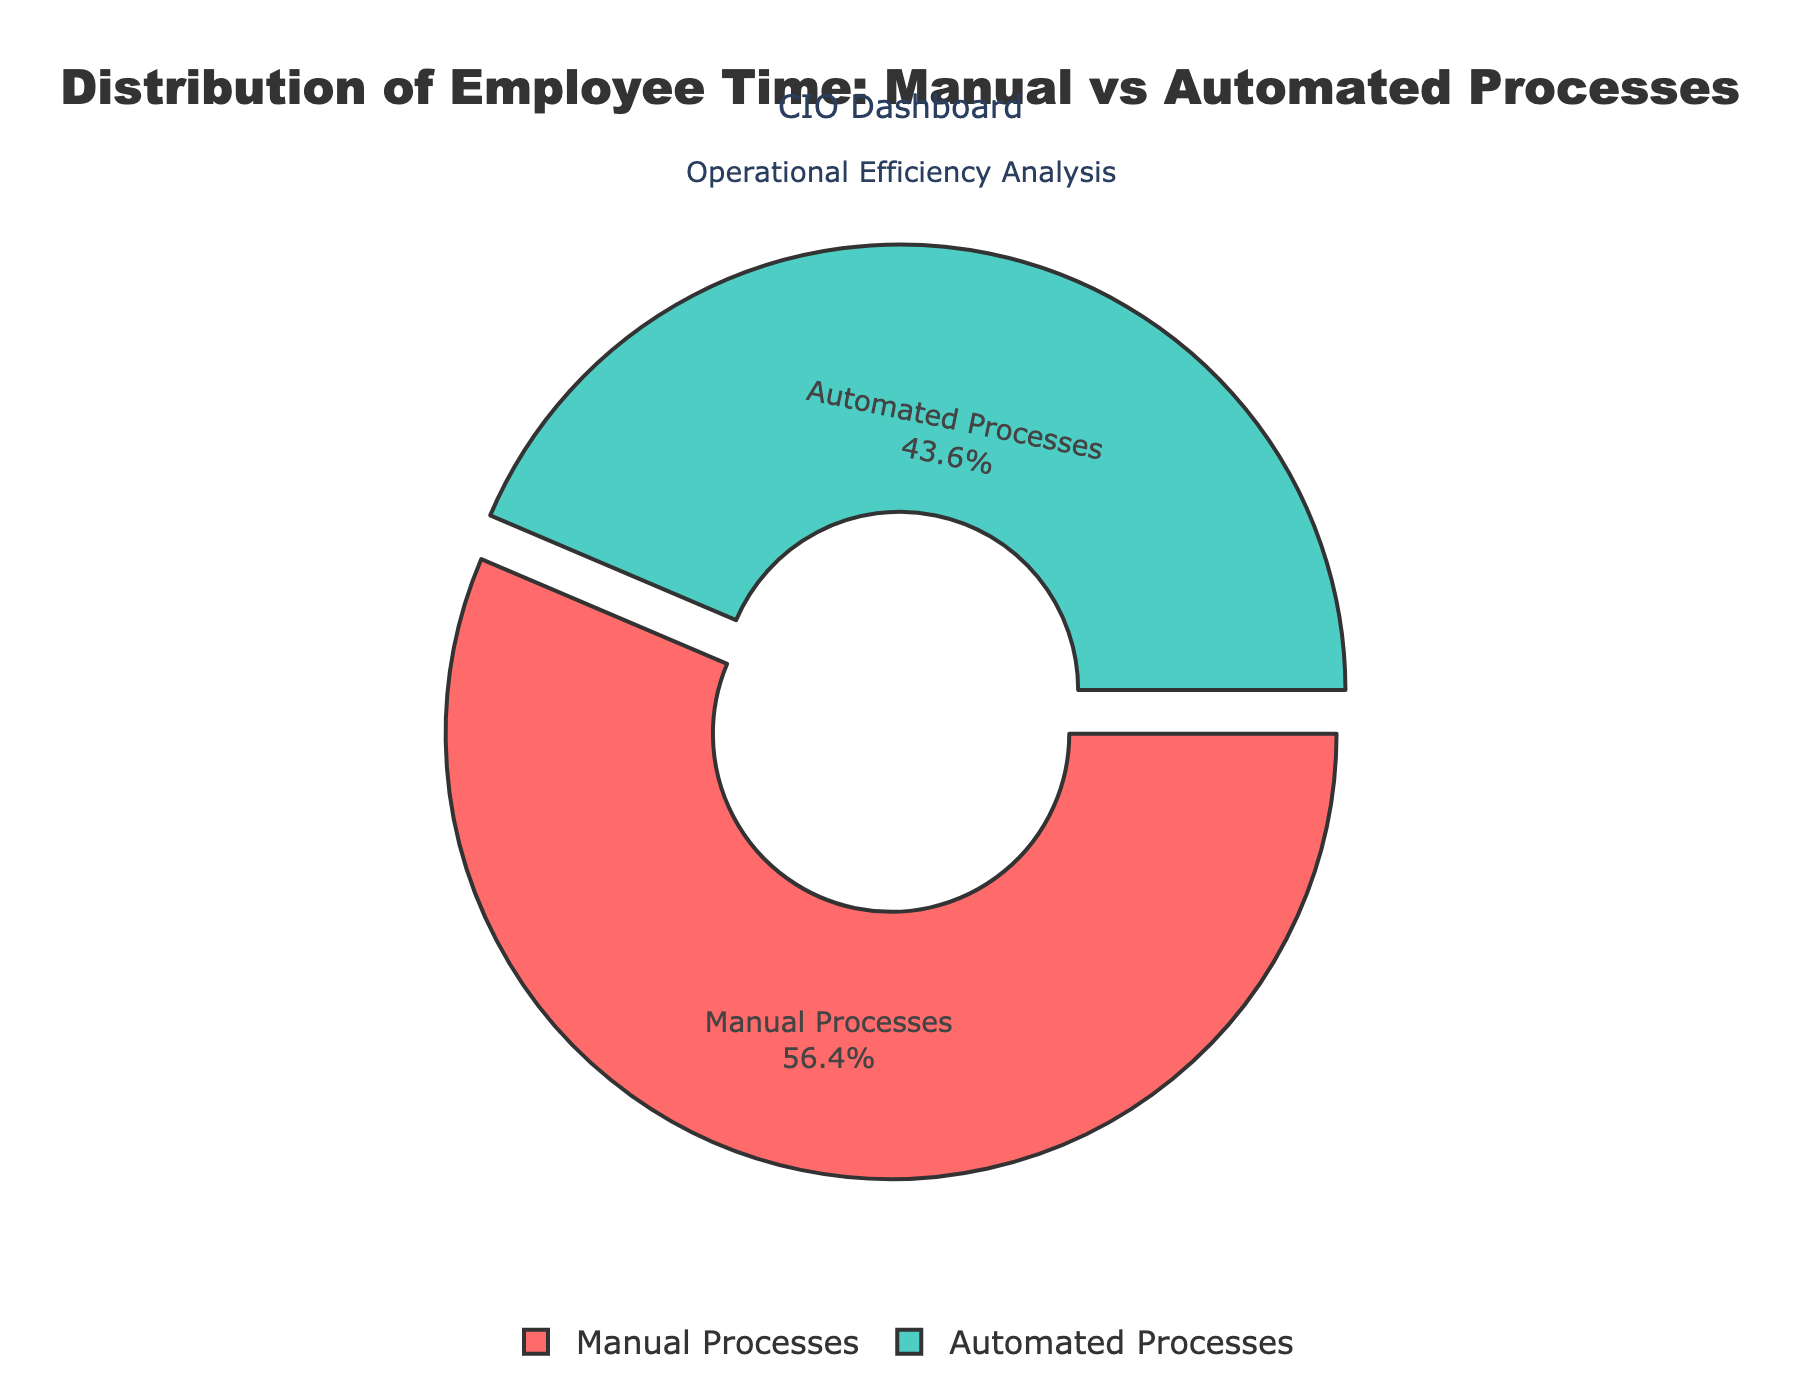What percentage of employee time is spent on manual processes compared to automated processes? The pie chart shows two segments, one for manual processes and one for automated processes. Looking at the chart, you can directly see the percentage labels.
Answer: Manual: 65%, Automated: 35% Which process type, manual or automated, occupies the larger portion of the pie chart? The pie chart segment labeled "Manual Processes" is larger than the one labeled "Automated Processes," which is evident by looking at the size of the sections.
Answer: Manual Processes What is the combined percentage of time spent on manual data entry and automated data processing? To find the combined percentage, sum the individual percentages for "Manual Data Entry" and "Automated Data Processing." The values are 25% and 35%, respectively. Adding these, 25 + 35 = 60%.
Answer: 60% Is the percentage of time spent on manual report generation greater than, less than, or equal to the time spent on automated reporting? Compare the pie chart segments labeled "Manual Report Generation" (15%) and "Automated Reporting" (20%). It's clear that 15% is less than 20%.
Answer: Less than What is the difference in percentage between time spent on manual compliance checks and automated compliance monitoring? Subtract the percentage for "Automated Compliance Monitoring" (8%) from "Manual Compliance Checks" (12%). So, 12 - 8 = 4%.
Answer: 4% How much more percentage of employee time is spent on manual customer service compared to automated customer support? Look at the pie chart segments labeled "Manual Customer Service" (30%) and "Automated Customer Support" (10%). Calculate the difference: 30 - 10 = 20% more on manual customer service.
Answer: 20% What proportion of employee time is spent on automated processes dedicated to risk management (risk scoring and compliance monitoring) compared to manual processes in the same category? Combine "Automated Risk Scoring" (5%) and "Automated Compliance Monitoring" (8%) for total automated time, which is 5 + 8 = 13%. Similarly, combine "Manual Risk Assessment" (10%) and "Manual Compliance Checks" (12%) for total manual time, which is 10 + 12 = 22%. Compare these two totals.
Answer: Automated: 13%, Manual: 22% What is the least time-consuming automated process? Identify the smallest segment in the automated processes category on the pie chart. "Automated Reconciliation" has the smallest percentage (7%).
Answer: Automated Reconciliation 